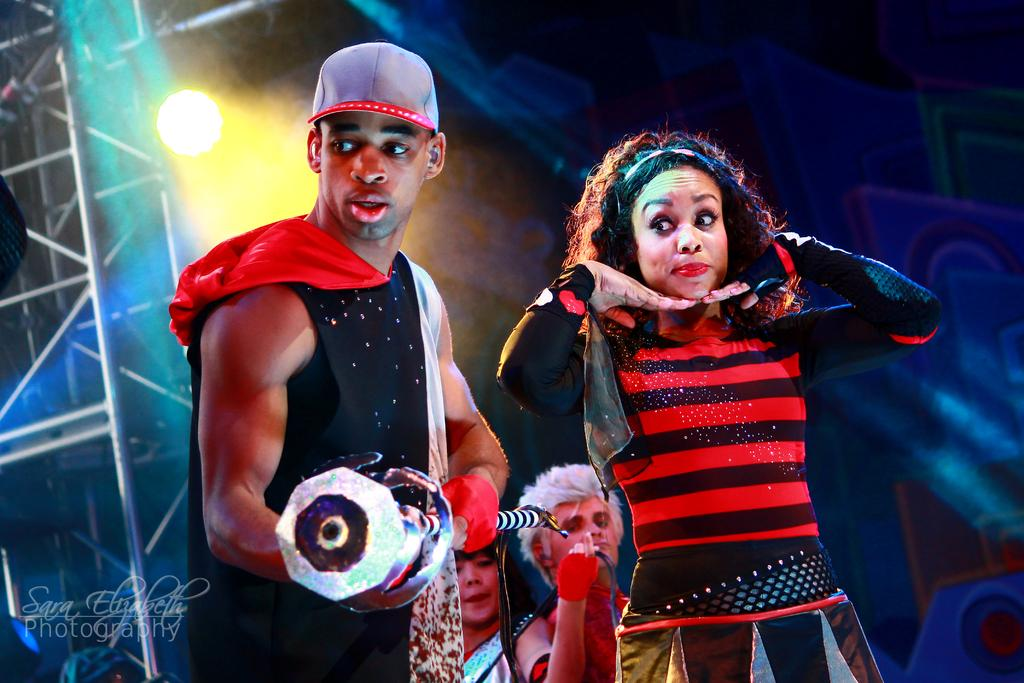What can be seen in the foreground of the image? There are persons standing in the front of the image. What is visible in the background of the image? There are lights and a stand in the background of the image. Are there any other people in the image besides those in the foreground? Yes, there are additional persons in the background of the image. What type of vase is being used by the persons in the image? There is no vase present in the image. Can you tell me how many tickets are being held by the persons in the image? There is no mention of tickets in the image. 